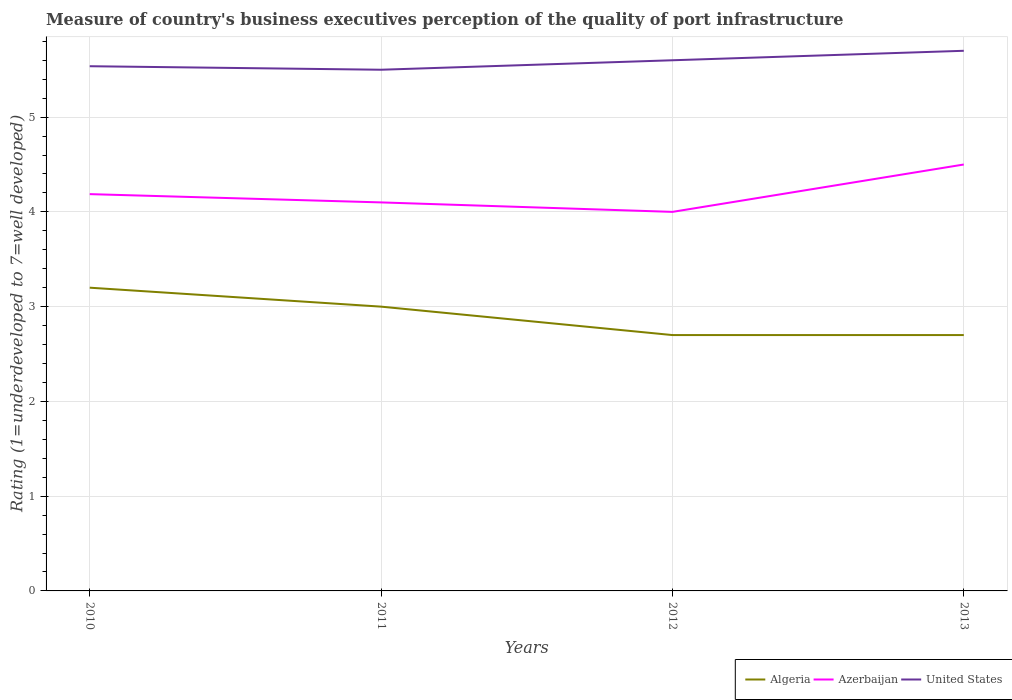How many different coloured lines are there?
Give a very brief answer. 3. Does the line corresponding to Azerbaijan intersect with the line corresponding to United States?
Your answer should be very brief. No. Is the number of lines equal to the number of legend labels?
Ensure brevity in your answer.  Yes. Across all years, what is the maximum ratings of the quality of port infrastructure in Algeria?
Ensure brevity in your answer.  2.7. In which year was the ratings of the quality of port infrastructure in United States maximum?
Make the answer very short. 2011. What is the total ratings of the quality of port infrastructure in Azerbaijan in the graph?
Keep it short and to the point. -0.31. What is the difference between the highest and the second highest ratings of the quality of port infrastructure in Algeria?
Give a very brief answer. 0.5. Is the ratings of the quality of port infrastructure in Azerbaijan strictly greater than the ratings of the quality of port infrastructure in Algeria over the years?
Your response must be concise. No. How many years are there in the graph?
Provide a short and direct response. 4. What is the difference between two consecutive major ticks on the Y-axis?
Give a very brief answer. 1. Are the values on the major ticks of Y-axis written in scientific E-notation?
Your answer should be compact. No. How many legend labels are there?
Provide a short and direct response. 3. What is the title of the graph?
Provide a succinct answer. Measure of country's business executives perception of the quality of port infrastructure. Does "China" appear as one of the legend labels in the graph?
Your response must be concise. No. What is the label or title of the Y-axis?
Your response must be concise. Rating (1=underdeveloped to 7=well developed). What is the Rating (1=underdeveloped to 7=well developed) of Algeria in 2010?
Provide a short and direct response. 3.2. What is the Rating (1=underdeveloped to 7=well developed) of Azerbaijan in 2010?
Keep it short and to the point. 4.19. What is the Rating (1=underdeveloped to 7=well developed) of United States in 2010?
Provide a short and direct response. 5.54. What is the Rating (1=underdeveloped to 7=well developed) in Azerbaijan in 2011?
Your answer should be very brief. 4.1. What is the Rating (1=underdeveloped to 7=well developed) in Azerbaijan in 2012?
Your answer should be very brief. 4. What is the Rating (1=underdeveloped to 7=well developed) of United States in 2012?
Provide a short and direct response. 5.6. What is the Rating (1=underdeveloped to 7=well developed) of Algeria in 2013?
Offer a very short reply. 2.7. What is the Rating (1=underdeveloped to 7=well developed) in Azerbaijan in 2013?
Keep it short and to the point. 4.5. What is the Rating (1=underdeveloped to 7=well developed) in United States in 2013?
Make the answer very short. 5.7. Across all years, what is the maximum Rating (1=underdeveloped to 7=well developed) in Algeria?
Ensure brevity in your answer.  3.2. Across all years, what is the maximum Rating (1=underdeveloped to 7=well developed) of Azerbaijan?
Make the answer very short. 4.5. Across all years, what is the minimum Rating (1=underdeveloped to 7=well developed) in Algeria?
Provide a short and direct response. 2.7. Across all years, what is the minimum Rating (1=underdeveloped to 7=well developed) of Azerbaijan?
Provide a short and direct response. 4. What is the total Rating (1=underdeveloped to 7=well developed) in Algeria in the graph?
Your response must be concise. 11.6. What is the total Rating (1=underdeveloped to 7=well developed) of Azerbaijan in the graph?
Your answer should be very brief. 16.79. What is the total Rating (1=underdeveloped to 7=well developed) of United States in the graph?
Your response must be concise. 22.34. What is the difference between the Rating (1=underdeveloped to 7=well developed) of Algeria in 2010 and that in 2011?
Provide a short and direct response. 0.2. What is the difference between the Rating (1=underdeveloped to 7=well developed) in Azerbaijan in 2010 and that in 2011?
Provide a short and direct response. 0.09. What is the difference between the Rating (1=underdeveloped to 7=well developed) in United States in 2010 and that in 2011?
Offer a terse response. 0.04. What is the difference between the Rating (1=underdeveloped to 7=well developed) in Algeria in 2010 and that in 2012?
Provide a succinct answer. 0.5. What is the difference between the Rating (1=underdeveloped to 7=well developed) in Azerbaijan in 2010 and that in 2012?
Offer a very short reply. 0.19. What is the difference between the Rating (1=underdeveloped to 7=well developed) in United States in 2010 and that in 2012?
Your response must be concise. -0.06. What is the difference between the Rating (1=underdeveloped to 7=well developed) in Azerbaijan in 2010 and that in 2013?
Your response must be concise. -0.31. What is the difference between the Rating (1=underdeveloped to 7=well developed) of United States in 2010 and that in 2013?
Offer a very short reply. -0.16. What is the difference between the Rating (1=underdeveloped to 7=well developed) in Azerbaijan in 2011 and that in 2012?
Your answer should be very brief. 0.1. What is the difference between the Rating (1=underdeveloped to 7=well developed) in Algeria in 2011 and that in 2013?
Offer a terse response. 0.3. What is the difference between the Rating (1=underdeveloped to 7=well developed) in Azerbaijan in 2012 and that in 2013?
Keep it short and to the point. -0.5. What is the difference between the Rating (1=underdeveloped to 7=well developed) in Algeria in 2010 and the Rating (1=underdeveloped to 7=well developed) in Azerbaijan in 2011?
Provide a short and direct response. -0.9. What is the difference between the Rating (1=underdeveloped to 7=well developed) of Algeria in 2010 and the Rating (1=underdeveloped to 7=well developed) of United States in 2011?
Offer a terse response. -2.3. What is the difference between the Rating (1=underdeveloped to 7=well developed) of Azerbaijan in 2010 and the Rating (1=underdeveloped to 7=well developed) of United States in 2011?
Your answer should be compact. -1.31. What is the difference between the Rating (1=underdeveloped to 7=well developed) in Algeria in 2010 and the Rating (1=underdeveloped to 7=well developed) in Azerbaijan in 2012?
Your response must be concise. -0.8. What is the difference between the Rating (1=underdeveloped to 7=well developed) in Algeria in 2010 and the Rating (1=underdeveloped to 7=well developed) in United States in 2012?
Make the answer very short. -2.4. What is the difference between the Rating (1=underdeveloped to 7=well developed) in Azerbaijan in 2010 and the Rating (1=underdeveloped to 7=well developed) in United States in 2012?
Offer a terse response. -1.41. What is the difference between the Rating (1=underdeveloped to 7=well developed) of Algeria in 2010 and the Rating (1=underdeveloped to 7=well developed) of United States in 2013?
Provide a short and direct response. -2.5. What is the difference between the Rating (1=underdeveloped to 7=well developed) in Azerbaijan in 2010 and the Rating (1=underdeveloped to 7=well developed) in United States in 2013?
Your answer should be compact. -1.51. What is the difference between the Rating (1=underdeveloped to 7=well developed) of Algeria in 2011 and the Rating (1=underdeveloped to 7=well developed) of Azerbaijan in 2013?
Give a very brief answer. -1.5. What is the difference between the Rating (1=underdeveloped to 7=well developed) of Algeria in 2011 and the Rating (1=underdeveloped to 7=well developed) of United States in 2013?
Your answer should be compact. -2.7. What is the difference between the Rating (1=underdeveloped to 7=well developed) of Azerbaijan in 2011 and the Rating (1=underdeveloped to 7=well developed) of United States in 2013?
Make the answer very short. -1.6. What is the difference between the Rating (1=underdeveloped to 7=well developed) in Algeria in 2012 and the Rating (1=underdeveloped to 7=well developed) in United States in 2013?
Give a very brief answer. -3. What is the average Rating (1=underdeveloped to 7=well developed) of Algeria per year?
Your answer should be very brief. 2.9. What is the average Rating (1=underdeveloped to 7=well developed) of Azerbaijan per year?
Offer a very short reply. 4.2. What is the average Rating (1=underdeveloped to 7=well developed) of United States per year?
Keep it short and to the point. 5.58. In the year 2010, what is the difference between the Rating (1=underdeveloped to 7=well developed) in Algeria and Rating (1=underdeveloped to 7=well developed) in Azerbaijan?
Make the answer very short. -0.99. In the year 2010, what is the difference between the Rating (1=underdeveloped to 7=well developed) in Algeria and Rating (1=underdeveloped to 7=well developed) in United States?
Keep it short and to the point. -2.34. In the year 2010, what is the difference between the Rating (1=underdeveloped to 7=well developed) of Azerbaijan and Rating (1=underdeveloped to 7=well developed) of United States?
Your answer should be very brief. -1.35. In the year 2011, what is the difference between the Rating (1=underdeveloped to 7=well developed) in Algeria and Rating (1=underdeveloped to 7=well developed) in Azerbaijan?
Your answer should be compact. -1.1. In the year 2011, what is the difference between the Rating (1=underdeveloped to 7=well developed) of Azerbaijan and Rating (1=underdeveloped to 7=well developed) of United States?
Your answer should be very brief. -1.4. In the year 2012, what is the difference between the Rating (1=underdeveloped to 7=well developed) of Algeria and Rating (1=underdeveloped to 7=well developed) of United States?
Provide a short and direct response. -2.9. In the year 2012, what is the difference between the Rating (1=underdeveloped to 7=well developed) in Azerbaijan and Rating (1=underdeveloped to 7=well developed) in United States?
Ensure brevity in your answer.  -1.6. In the year 2013, what is the difference between the Rating (1=underdeveloped to 7=well developed) in Azerbaijan and Rating (1=underdeveloped to 7=well developed) in United States?
Offer a very short reply. -1.2. What is the ratio of the Rating (1=underdeveloped to 7=well developed) of Algeria in 2010 to that in 2011?
Provide a succinct answer. 1.07. What is the ratio of the Rating (1=underdeveloped to 7=well developed) in Azerbaijan in 2010 to that in 2011?
Ensure brevity in your answer.  1.02. What is the ratio of the Rating (1=underdeveloped to 7=well developed) in United States in 2010 to that in 2011?
Your response must be concise. 1.01. What is the ratio of the Rating (1=underdeveloped to 7=well developed) in Algeria in 2010 to that in 2012?
Give a very brief answer. 1.19. What is the ratio of the Rating (1=underdeveloped to 7=well developed) of Azerbaijan in 2010 to that in 2012?
Give a very brief answer. 1.05. What is the ratio of the Rating (1=underdeveloped to 7=well developed) in United States in 2010 to that in 2012?
Provide a succinct answer. 0.99. What is the ratio of the Rating (1=underdeveloped to 7=well developed) in Algeria in 2010 to that in 2013?
Provide a succinct answer. 1.19. What is the ratio of the Rating (1=underdeveloped to 7=well developed) of Azerbaijan in 2010 to that in 2013?
Ensure brevity in your answer.  0.93. What is the ratio of the Rating (1=underdeveloped to 7=well developed) of United States in 2010 to that in 2013?
Keep it short and to the point. 0.97. What is the ratio of the Rating (1=underdeveloped to 7=well developed) in United States in 2011 to that in 2012?
Your answer should be compact. 0.98. What is the ratio of the Rating (1=underdeveloped to 7=well developed) in Algeria in 2011 to that in 2013?
Give a very brief answer. 1.11. What is the ratio of the Rating (1=underdeveloped to 7=well developed) in Azerbaijan in 2011 to that in 2013?
Your answer should be very brief. 0.91. What is the ratio of the Rating (1=underdeveloped to 7=well developed) in United States in 2011 to that in 2013?
Your answer should be compact. 0.96. What is the ratio of the Rating (1=underdeveloped to 7=well developed) in Azerbaijan in 2012 to that in 2013?
Your answer should be very brief. 0.89. What is the ratio of the Rating (1=underdeveloped to 7=well developed) of United States in 2012 to that in 2013?
Provide a short and direct response. 0.98. What is the difference between the highest and the second highest Rating (1=underdeveloped to 7=well developed) of Azerbaijan?
Offer a terse response. 0.31. What is the difference between the highest and the lowest Rating (1=underdeveloped to 7=well developed) of Algeria?
Your answer should be very brief. 0.5. What is the difference between the highest and the lowest Rating (1=underdeveloped to 7=well developed) of Azerbaijan?
Your answer should be compact. 0.5. 